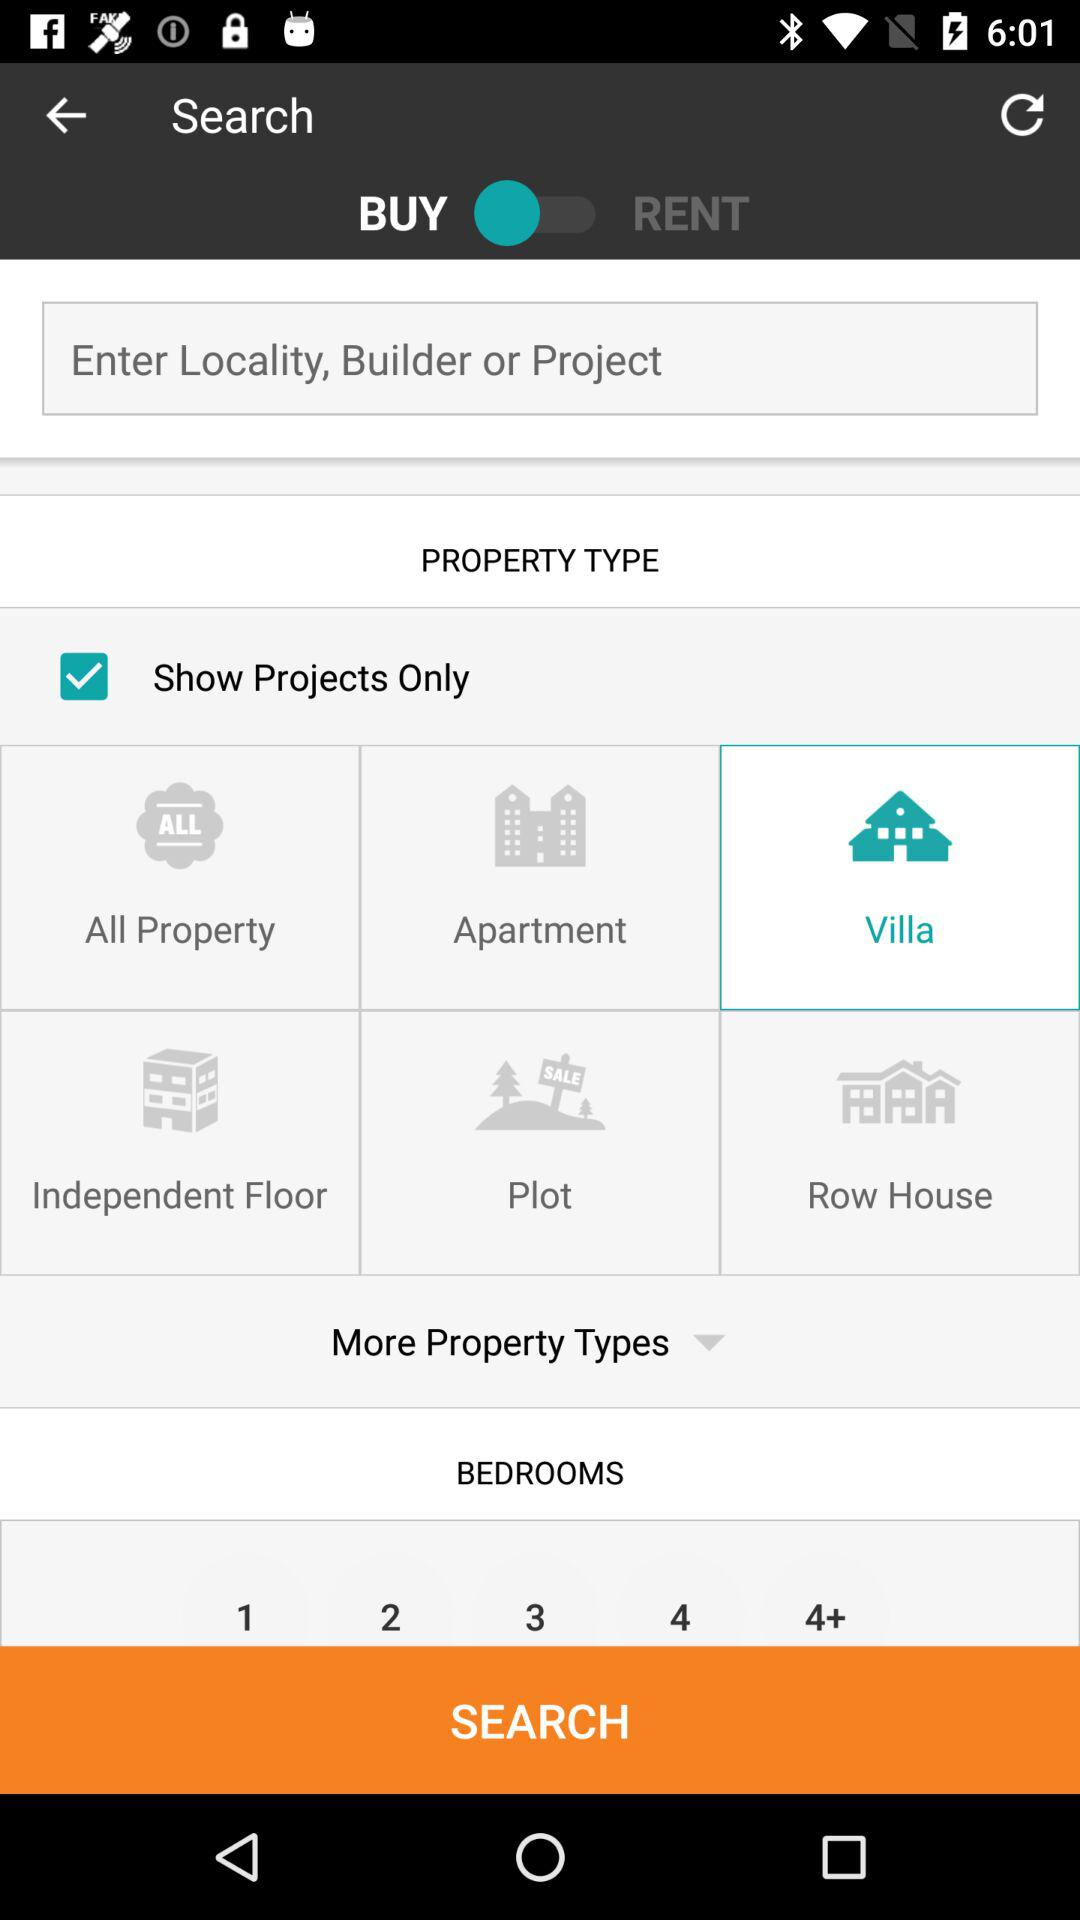Which type of property has been selected? The selected property type is "Villa". 